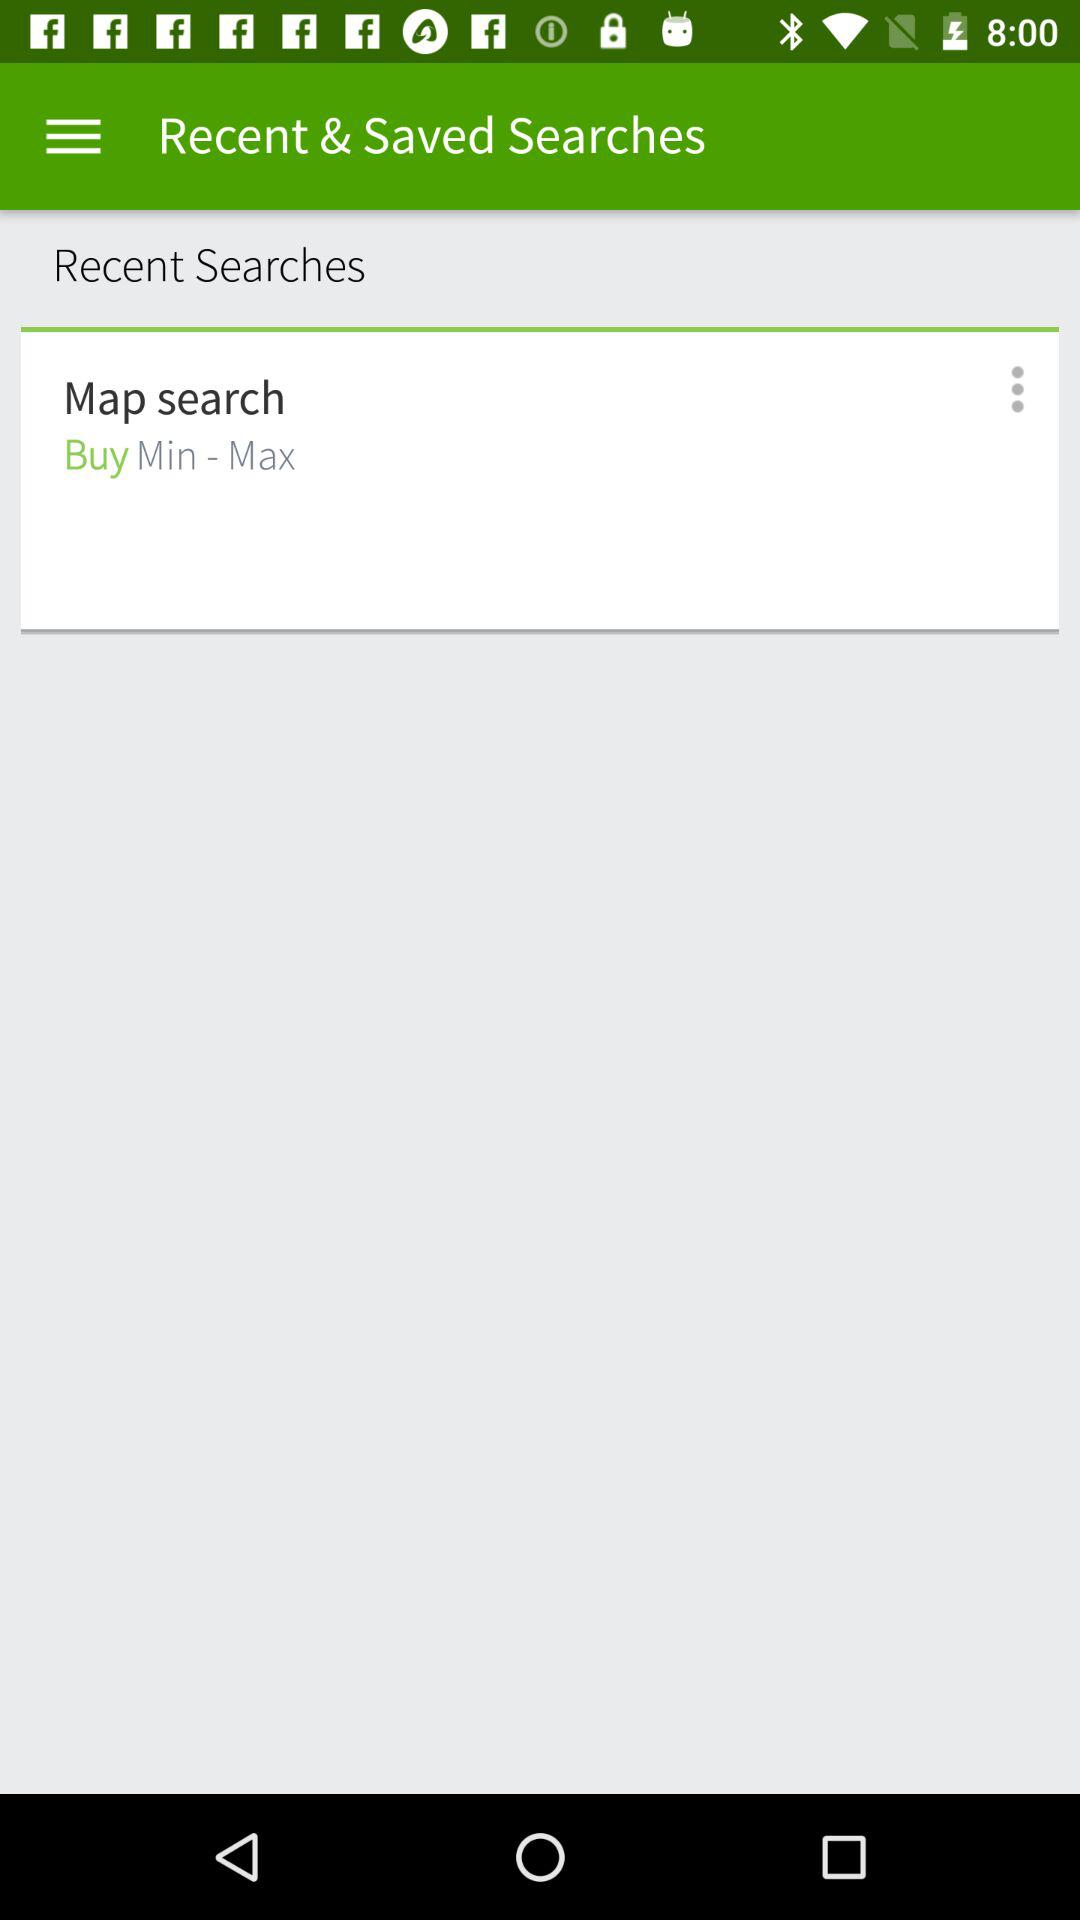What is the recent search? The recent search is "Map search". 